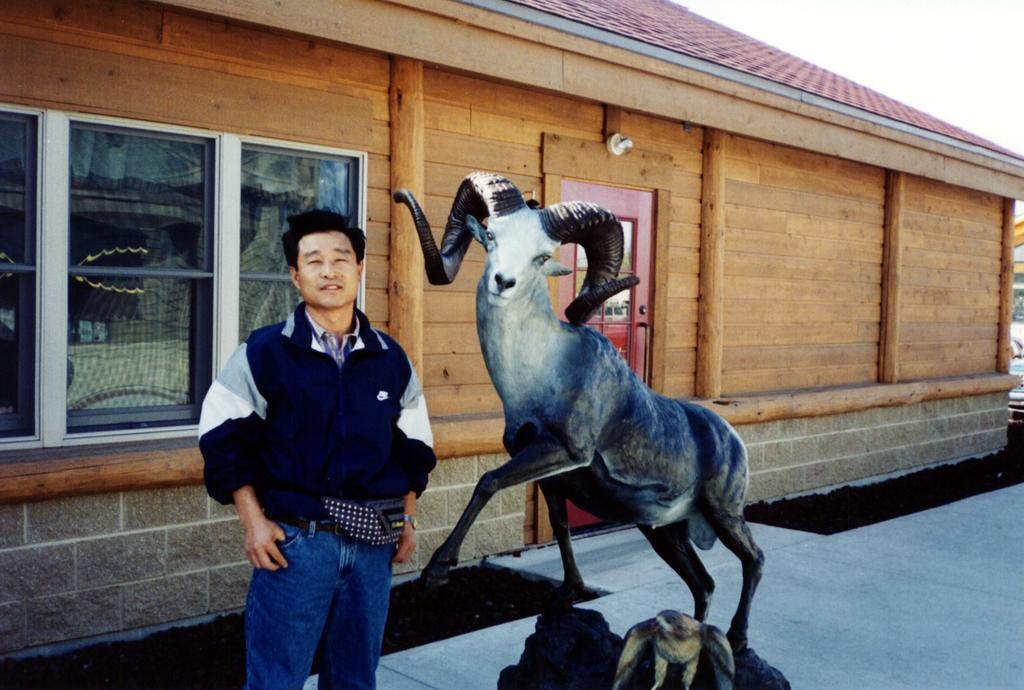What is the main subject of the image? There is a person standing and posing for a photo in the image. What other object or structure is present in the image? There is a statue in the image. What can be seen in the background of the image? There is a house in the background of the image. What features does the house have? The house has a door and windows. What type of fork is the person using to pose for the photo? There is no fork present in the image, and the person is not using any utensils to pose for the photo. 